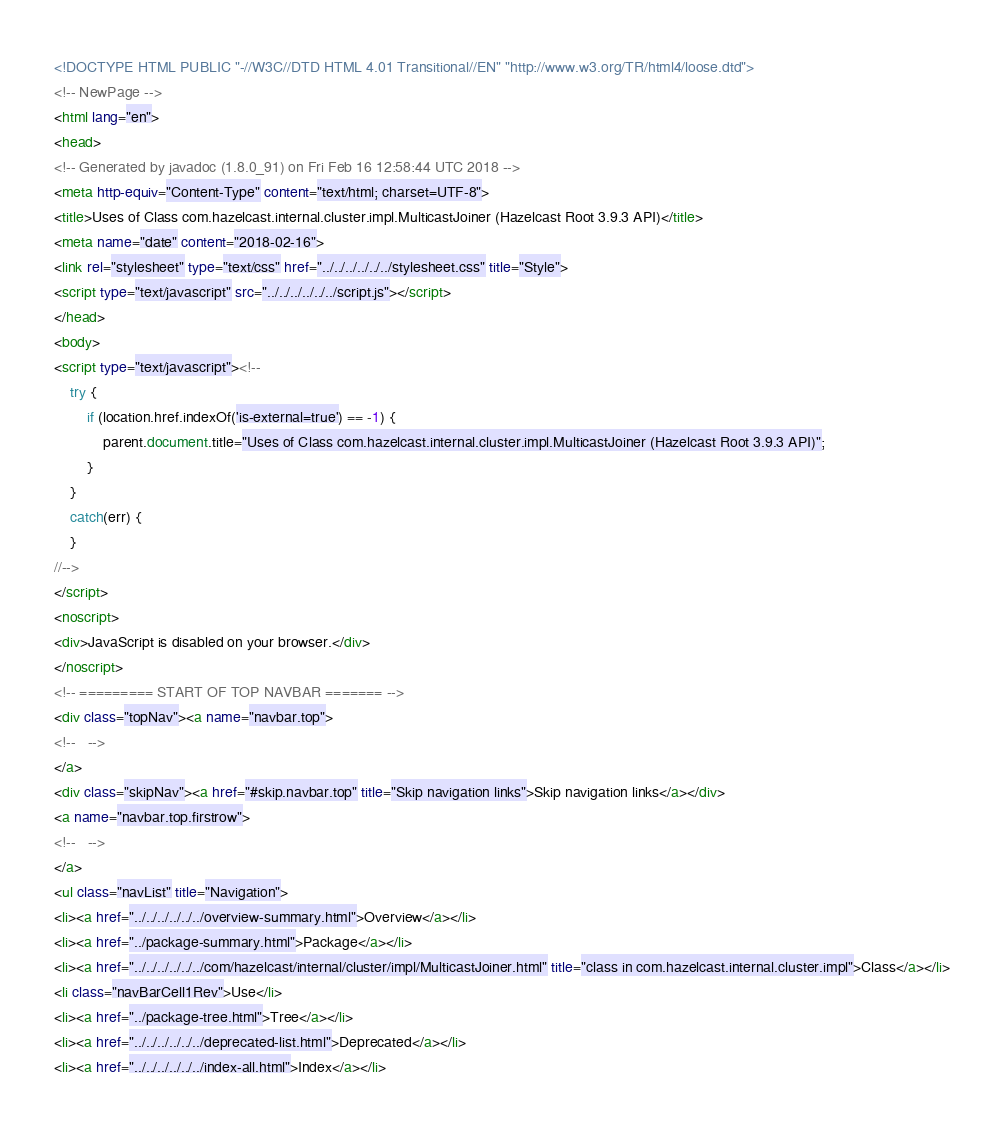<code> <loc_0><loc_0><loc_500><loc_500><_HTML_><!DOCTYPE HTML PUBLIC "-//W3C//DTD HTML 4.01 Transitional//EN" "http://www.w3.org/TR/html4/loose.dtd">
<!-- NewPage -->
<html lang="en">
<head>
<!-- Generated by javadoc (1.8.0_91) on Fri Feb 16 12:58:44 UTC 2018 -->
<meta http-equiv="Content-Type" content="text/html; charset=UTF-8">
<title>Uses of Class com.hazelcast.internal.cluster.impl.MulticastJoiner (Hazelcast Root 3.9.3 API)</title>
<meta name="date" content="2018-02-16">
<link rel="stylesheet" type="text/css" href="../../../../../../stylesheet.css" title="Style">
<script type="text/javascript" src="../../../../../../script.js"></script>
</head>
<body>
<script type="text/javascript"><!--
    try {
        if (location.href.indexOf('is-external=true') == -1) {
            parent.document.title="Uses of Class com.hazelcast.internal.cluster.impl.MulticastJoiner (Hazelcast Root 3.9.3 API)";
        }
    }
    catch(err) {
    }
//-->
</script>
<noscript>
<div>JavaScript is disabled on your browser.</div>
</noscript>
<!-- ========= START OF TOP NAVBAR ======= -->
<div class="topNav"><a name="navbar.top">
<!--   -->
</a>
<div class="skipNav"><a href="#skip.navbar.top" title="Skip navigation links">Skip navigation links</a></div>
<a name="navbar.top.firstrow">
<!--   -->
</a>
<ul class="navList" title="Navigation">
<li><a href="../../../../../../overview-summary.html">Overview</a></li>
<li><a href="../package-summary.html">Package</a></li>
<li><a href="../../../../../../com/hazelcast/internal/cluster/impl/MulticastJoiner.html" title="class in com.hazelcast.internal.cluster.impl">Class</a></li>
<li class="navBarCell1Rev">Use</li>
<li><a href="../package-tree.html">Tree</a></li>
<li><a href="../../../../../../deprecated-list.html">Deprecated</a></li>
<li><a href="../../../../../../index-all.html">Index</a></li></code> 